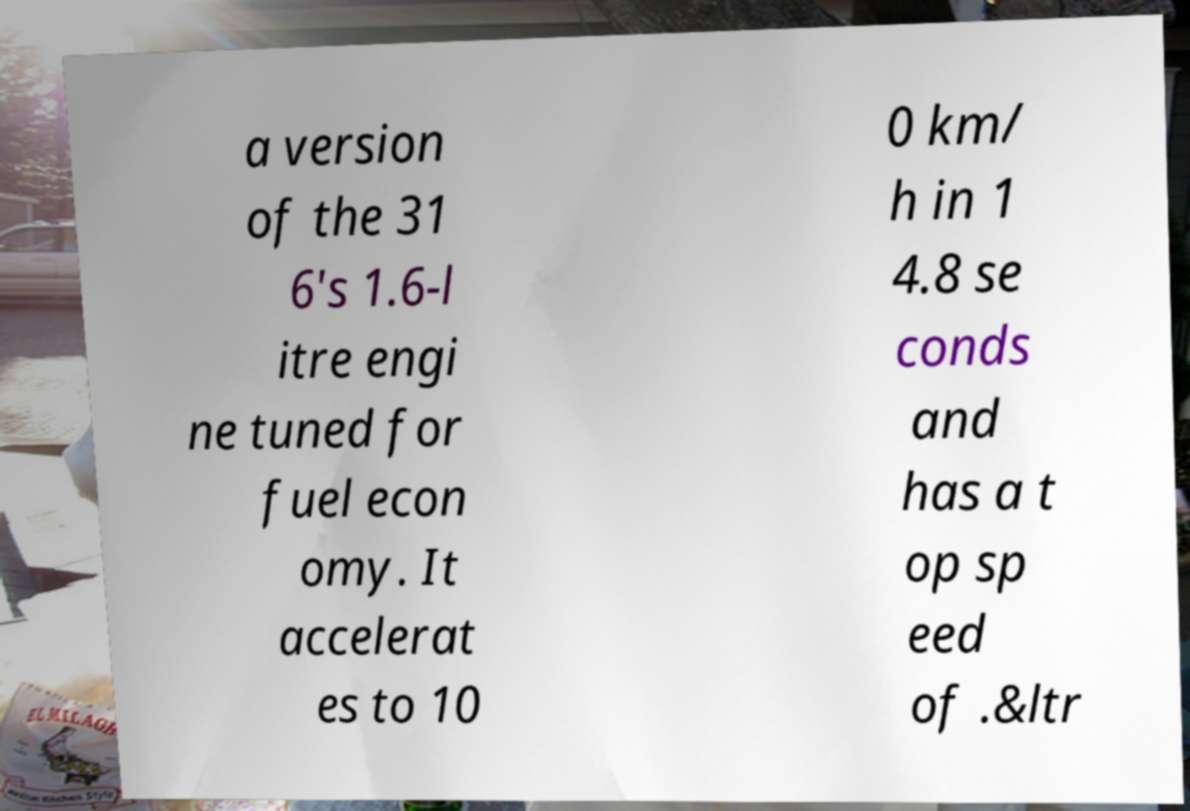Can you accurately transcribe the text from the provided image for me? a version of the 31 6's 1.6-l itre engi ne tuned for fuel econ omy. It accelerat es to 10 0 km/ h in 1 4.8 se conds and has a t op sp eed of .&ltr 